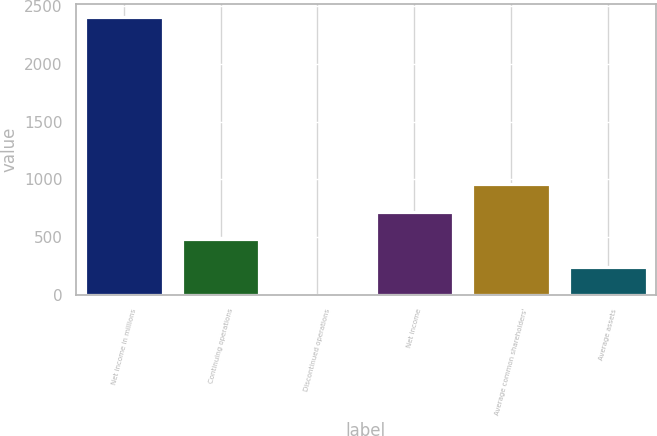Convert chart to OTSL. <chart><loc_0><loc_0><loc_500><loc_500><bar_chart><fcel>Net income in millions<fcel>Continuing operations<fcel>Discontinued operations<fcel>Net income<fcel>Average common shareholders'<fcel>Average assets<nl><fcel>2403<fcel>480.68<fcel>0.1<fcel>720.97<fcel>961.26<fcel>240.39<nl></chart> 